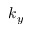<formula> <loc_0><loc_0><loc_500><loc_500>k _ { y }</formula> 